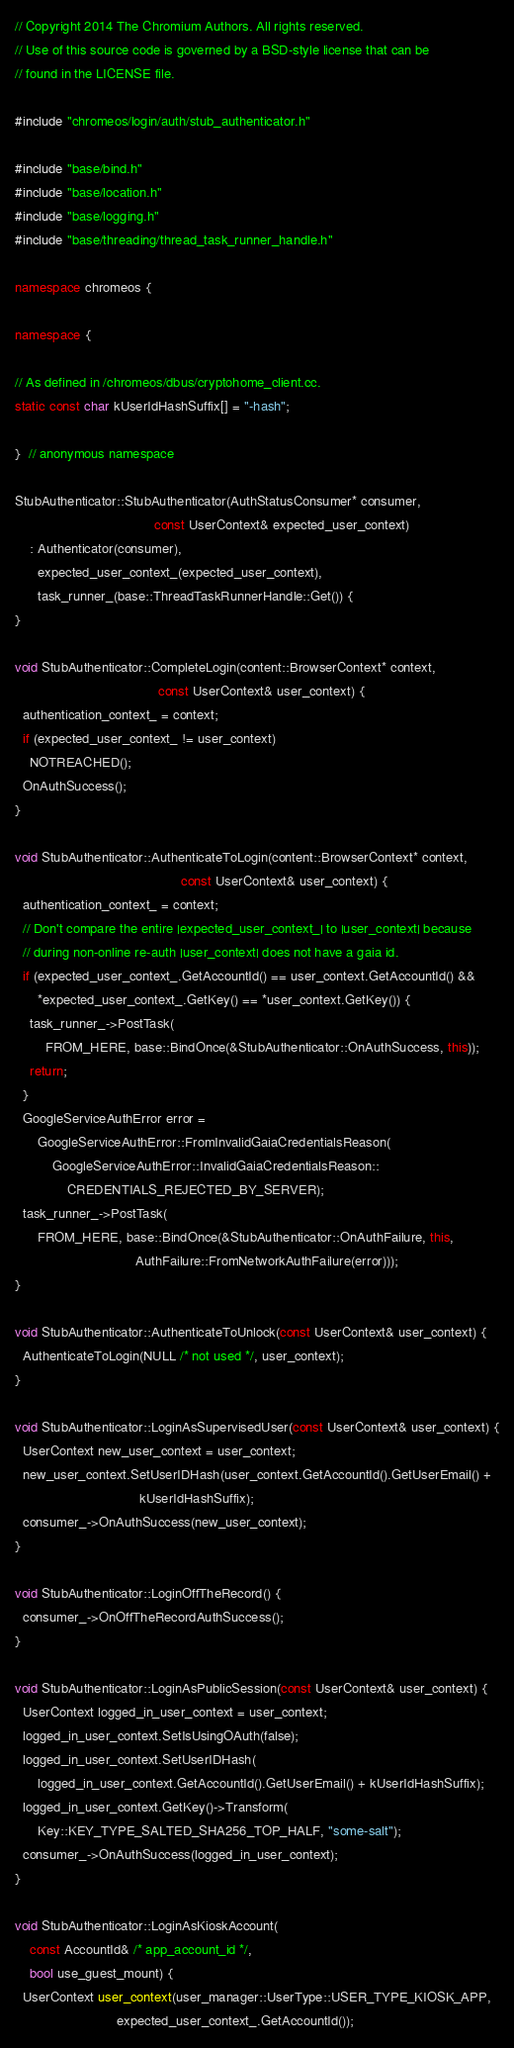Convert code to text. <code><loc_0><loc_0><loc_500><loc_500><_C++_>// Copyright 2014 The Chromium Authors. All rights reserved.
// Use of this source code is governed by a BSD-style license that can be
// found in the LICENSE file.

#include "chromeos/login/auth/stub_authenticator.h"

#include "base/bind.h"
#include "base/location.h"
#include "base/logging.h"
#include "base/threading/thread_task_runner_handle.h"

namespace chromeos {

namespace {

// As defined in /chromeos/dbus/cryptohome_client.cc.
static const char kUserIdHashSuffix[] = "-hash";

}  // anonymous namespace

StubAuthenticator::StubAuthenticator(AuthStatusConsumer* consumer,
                                     const UserContext& expected_user_context)
    : Authenticator(consumer),
      expected_user_context_(expected_user_context),
      task_runner_(base::ThreadTaskRunnerHandle::Get()) {
}

void StubAuthenticator::CompleteLogin(content::BrowserContext* context,
                                      const UserContext& user_context) {
  authentication_context_ = context;
  if (expected_user_context_ != user_context)
    NOTREACHED();
  OnAuthSuccess();
}

void StubAuthenticator::AuthenticateToLogin(content::BrowserContext* context,
                                            const UserContext& user_context) {
  authentication_context_ = context;
  // Don't compare the entire |expected_user_context_| to |user_context| because
  // during non-online re-auth |user_context| does not have a gaia id.
  if (expected_user_context_.GetAccountId() == user_context.GetAccountId() &&
      *expected_user_context_.GetKey() == *user_context.GetKey()) {
    task_runner_->PostTask(
        FROM_HERE, base::BindOnce(&StubAuthenticator::OnAuthSuccess, this));
    return;
  }
  GoogleServiceAuthError error =
      GoogleServiceAuthError::FromInvalidGaiaCredentialsReason(
          GoogleServiceAuthError::InvalidGaiaCredentialsReason::
              CREDENTIALS_REJECTED_BY_SERVER);
  task_runner_->PostTask(
      FROM_HERE, base::BindOnce(&StubAuthenticator::OnAuthFailure, this,
                                AuthFailure::FromNetworkAuthFailure(error)));
}

void StubAuthenticator::AuthenticateToUnlock(const UserContext& user_context) {
  AuthenticateToLogin(NULL /* not used */, user_context);
}

void StubAuthenticator::LoginAsSupervisedUser(const UserContext& user_context) {
  UserContext new_user_context = user_context;
  new_user_context.SetUserIDHash(user_context.GetAccountId().GetUserEmail() +
                                 kUserIdHashSuffix);
  consumer_->OnAuthSuccess(new_user_context);
}

void StubAuthenticator::LoginOffTheRecord() {
  consumer_->OnOffTheRecordAuthSuccess();
}

void StubAuthenticator::LoginAsPublicSession(const UserContext& user_context) {
  UserContext logged_in_user_context = user_context;
  logged_in_user_context.SetIsUsingOAuth(false);
  logged_in_user_context.SetUserIDHash(
      logged_in_user_context.GetAccountId().GetUserEmail() + kUserIdHashSuffix);
  logged_in_user_context.GetKey()->Transform(
      Key::KEY_TYPE_SALTED_SHA256_TOP_HALF, "some-salt");
  consumer_->OnAuthSuccess(logged_in_user_context);
}

void StubAuthenticator::LoginAsKioskAccount(
    const AccountId& /* app_account_id */,
    bool use_guest_mount) {
  UserContext user_context(user_manager::UserType::USER_TYPE_KIOSK_APP,
                           expected_user_context_.GetAccountId());</code> 